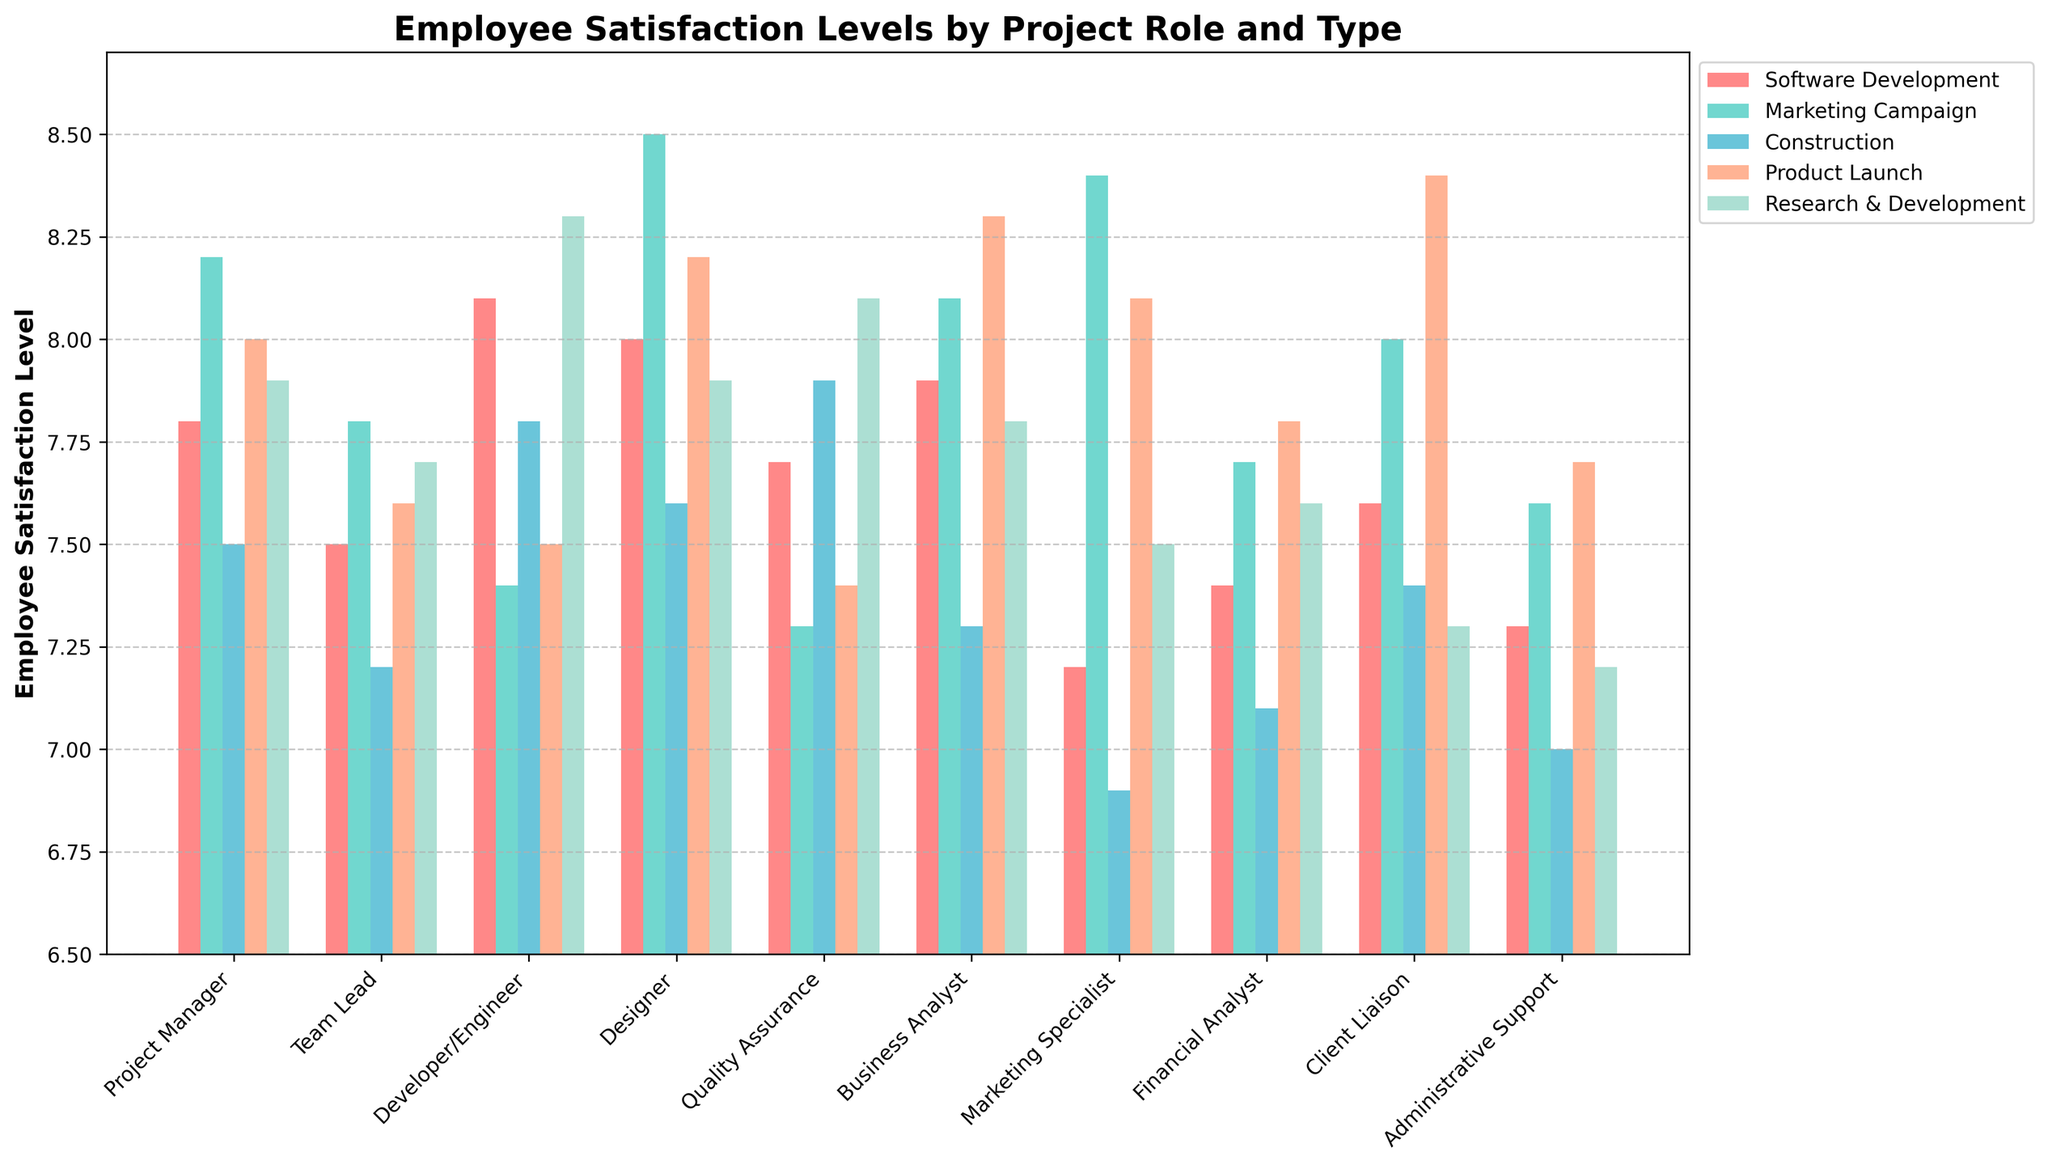Which project role has the highest employee satisfaction level for the "Marketing Campaign" project type? By looking at the height of the bars in the "Marketing Campaign" category, the "Designer" role has the tallest bar, indicating the highest satisfaction level.
Answer: Designer How does the satisfaction level of the "Developer/Engineer" role in "Software Development" compare to the "Product Launch"? The bar for "Developer/Engineer" in "Software Development" is taller than in "Product Launch." Specifically, Software Development is at 8.1, while Product Launch is at 7.5.
Answer: Software Development is higher Which roles have satisfaction levels greater than 8 for the "Product Launch" project type? By checking the height of the bars in the "Product Launch" section, "Client Liaison" (8.4), "Business Analyst" (8.3), "Designer" (8.2), and "Marketing Specialist" (8.1) have bars taller than 8.
Answer: Client Liaison, Business Analyst, Designer, Marketing Specialist What's the average employee satisfaction level for "Quality Assurance" across all project types? Add the satisfaction levels of "Quality Assurance" for each project type: (7.7 + 7.3 + 7.9 + 7.4 + 8.1) = 38.4. Divide by the number of project types, which is 5. 38.4/5 = 7.68.
Answer: 7.68 Which project type has the lowest average satisfaction level across all roles? Calculate the average for each project type and compare. For "Software Development": (7.8 + 7.5 + 8.1 + 8.0 + 7.7 + 7.9 + 7.2 + 7.4 + 7.6 + 7.3)/10 = 7.65. Repeat for other project types. The lowest average comes out for "Construction".
Answer: Construction Compare the employee satisfaction between "Team Lead" and "Project Manager" roles within "Research & Development." The "Project Manager" role has a satisfaction level of 7.9 while the "Team Lead" role has a satisfaction level of 7.7 in Research & Development.
Answer: Project Manager is higher What is the median employee satisfaction level for "Marketing Specialist" across project types? To find the median, sort the satisfaction levels: (6.9, 7.2, 7.5, 8.1, 8.4). The middle value is 7.5.
Answer: 7.5 How many roles have satisfaction levels below 7.5 for "Construction"? Count the roles with bars lower than 7.5 in the "Construction" category: "Marketing Specialist" (6.9), "Administrative Support" (7.0), "Financial Analyst" (7.1), "Business Analyst" (7.3), "Developer/Engineer" (7.4), "Client Liaison" (7.4). Total: 6 roles.
Answer: 6 roles 